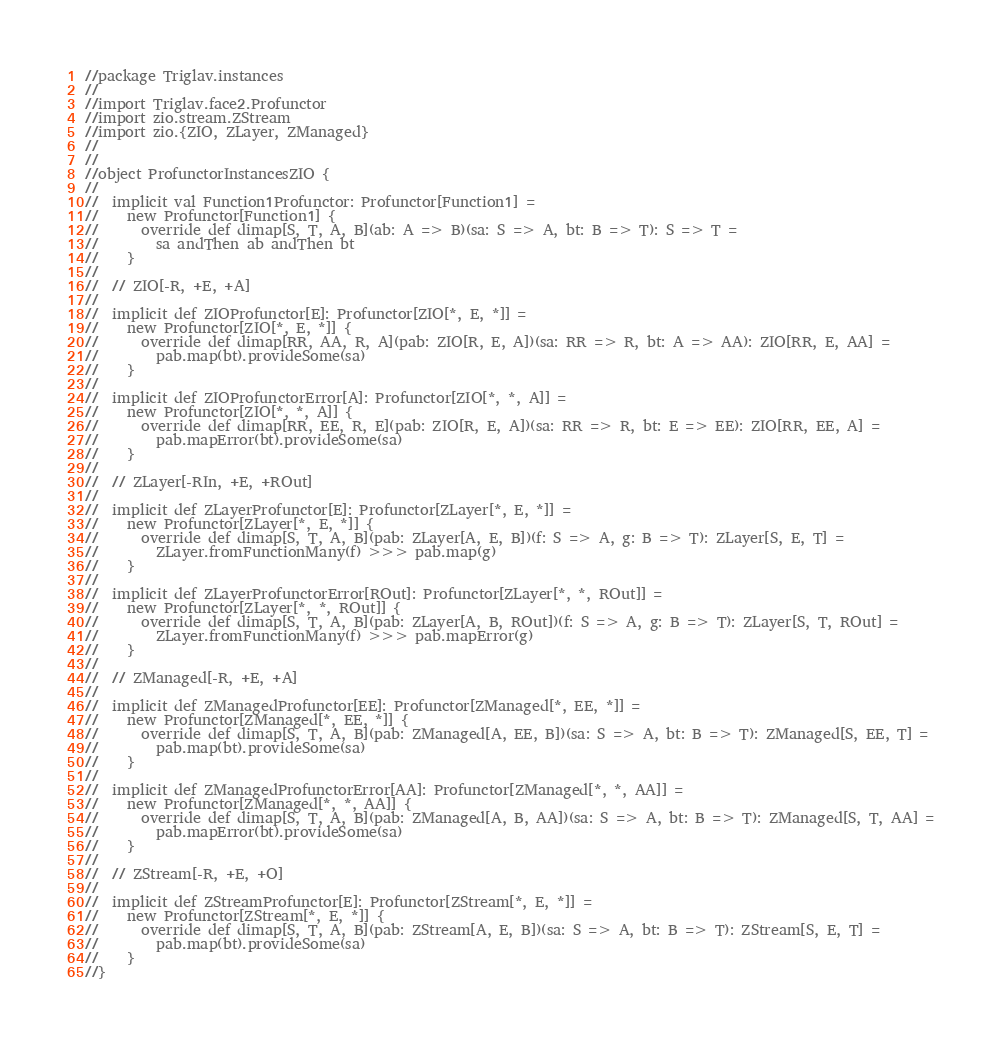<code> <loc_0><loc_0><loc_500><loc_500><_Scala_>//package Triglav.instances
//
//import Triglav.face2.Profunctor
//import zio.stream.ZStream
//import zio.{ZIO, ZLayer, ZManaged}
//
//
//object ProfunctorInstancesZIO {
//
//  implicit val Function1Profunctor: Profunctor[Function1] =
//    new Profunctor[Function1] {
//      override def dimap[S, T, A, B](ab: A => B)(sa: S => A, bt: B => T): S => T =
//        sa andThen ab andThen bt
//    }
//
//  // ZIO[-R, +E, +A]
//
//  implicit def ZIOProfunctor[E]: Profunctor[ZIO[*, E, *]] =
//    new Profunctor[ZIO[*, E, *]] {
//      override def dimap[RR, AA, R, A](pab: ZIO[R, E, A])(sa: RR => R, bt: A => AA): ZIO[RR, E, AA] =
//        pab.map(bt).provideSome(sa)
//    }
//
//  implicit def ZIOProfunctorError[A]: Profunctor[ZIO[*, *, A]] =
//    new Profunctor[ZIO[*, *, A]] {
//      override def dimap[RR, EE, R, E](pab: ZIO[R, E, A])(sa: RR => R, bt: E => EE): ZIO[RR, EE, A] =
//        pab.mapError(bt).provideSome(sa)
//    }
//
//  // ZLayer[-RIn, +E, +ROut]
//
//  implicit def ZLayerProfunctor[E]: Profunctor[ZLayer[*, E, *]] =
//    new Profunctor[ZLayer[*, E, *]] {
//      override def dimap[S, T, A, B](pab: ZLayer[A, E, B])(f: S => A, g: B => T): ZLayer[S, E, T] =
//        ZLayer.fromFunctionMany(f) >>> pab.map(g)
//    }
//
//  implicit def ZLayerProfunctorError[ROut]: Profunctor[ZLayer[*, *, ROut]] =
//    new Profunctor[ZLayer[*, *, ROut]] {
//      override def dimap[S, T, A, B](pab: ZLayer[A, B, ROut])(f: S => A, g: B => T): ZLayer[S, T, ROut] =
//        ZLayer.fromFunctionMany(f) >>> pab.mapError(g)
//    }
//
//  // ZManaged[-R, +E, +A]
//
//  implicit def ZManagedProfunctor[EE]: Profunctor[ZManaged[*, EE, *]] =
//    new Profunctor[ZManaged[*, EE, *]] {
//      override def dimap[S, T, A, B](pab: ZManaged[A, EE, B])(sa: S => A, bt: B => T): ZManaged[S, EE, T] =
//        pab.map(bt).provideSome(sa)
//    }
//
//  implicit def ZManagedProfunctorError[AA]: Profunctor[ZManaged[*, *, AA]] =
//    new Profunctor[ZManaged[*, *, AA]] {
//      override def dimap[S, T, A, B](pab: ZManaged[A, B, AA])(sa: S => A, bt: B => T): ZManaged[S, T, AA] =
//        pab.mapError(bt).provideSome(sa)
//    }
//
//  // ZStream[-R, +E, +O]
//
//  implicit def ZStreamProfunctor[E]: Profunctor[ZStream[*, E, *]] =
//    new Profunctor[ZStream[*, E, *]] {
//      override def dimap[S, T, A, B](pab: ZStream[A, E, B])(sa: S => A, bt: B => T): ZStream[S, E, T] =
//        pab.map(bt).provideSome(sa)
//    }
//}
</code> 